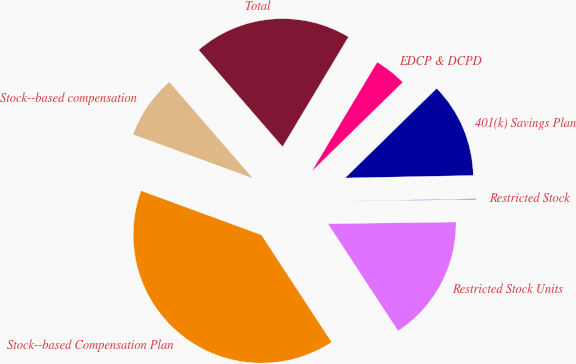Convert chart to OTSL. <chart><loc_0><loc_0><loc_500><loc_500><pie_chart><fcel>Stock-­based Compensation Plan<fcel>Restricted Stock Units<fcel>Restricted Stock<fcel>401(k) Savings Plan<fcel>EDCP & DCPD<fcel>Total<fcel>Stock-­based compensation<nl><fcel>39.82%<fcel>15.99%<fcel>0.1%<fcel>12.02%<fcel>4.07%<fcel>19.96%<fcel>8.04%<nl></chart> 